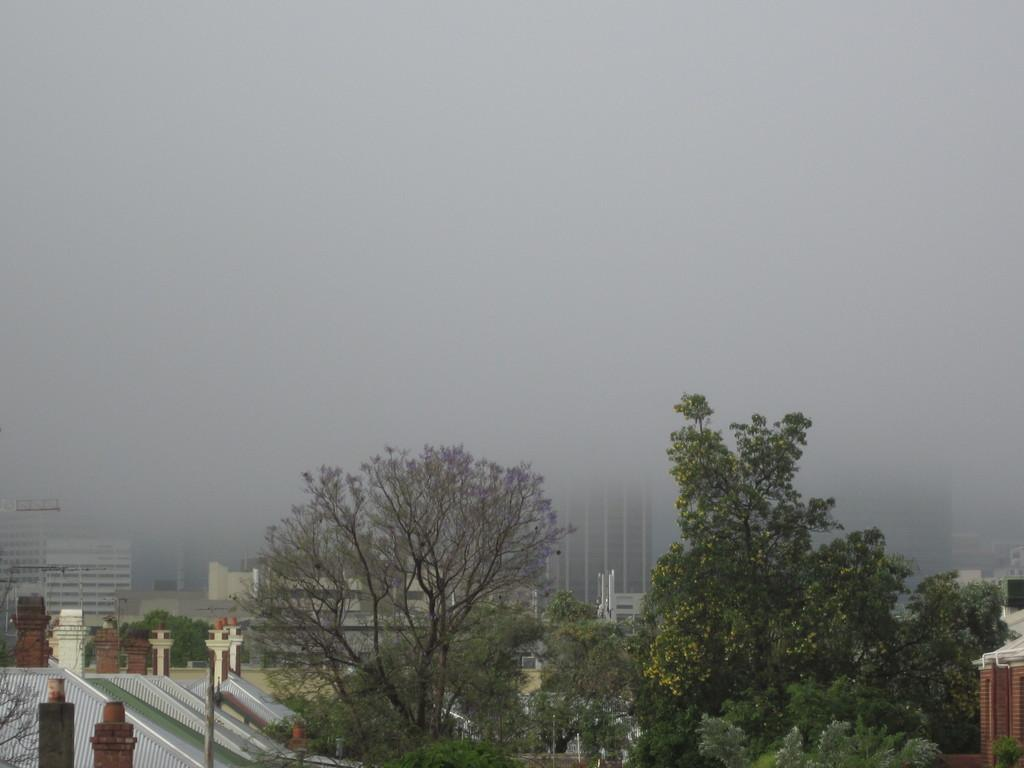What type of vegetation can be seen in the image? There are trees in the image. What structures are visible in the background of the image? There are houses and buildings in the background of the image. What atmospheric condition is present in the background of the image? Fog is visible in the background of the image. What type of cakes are being served at the historical event in the image? There is no historical event or cakes present in the image; it features trees, houses, buildings, and fog. 